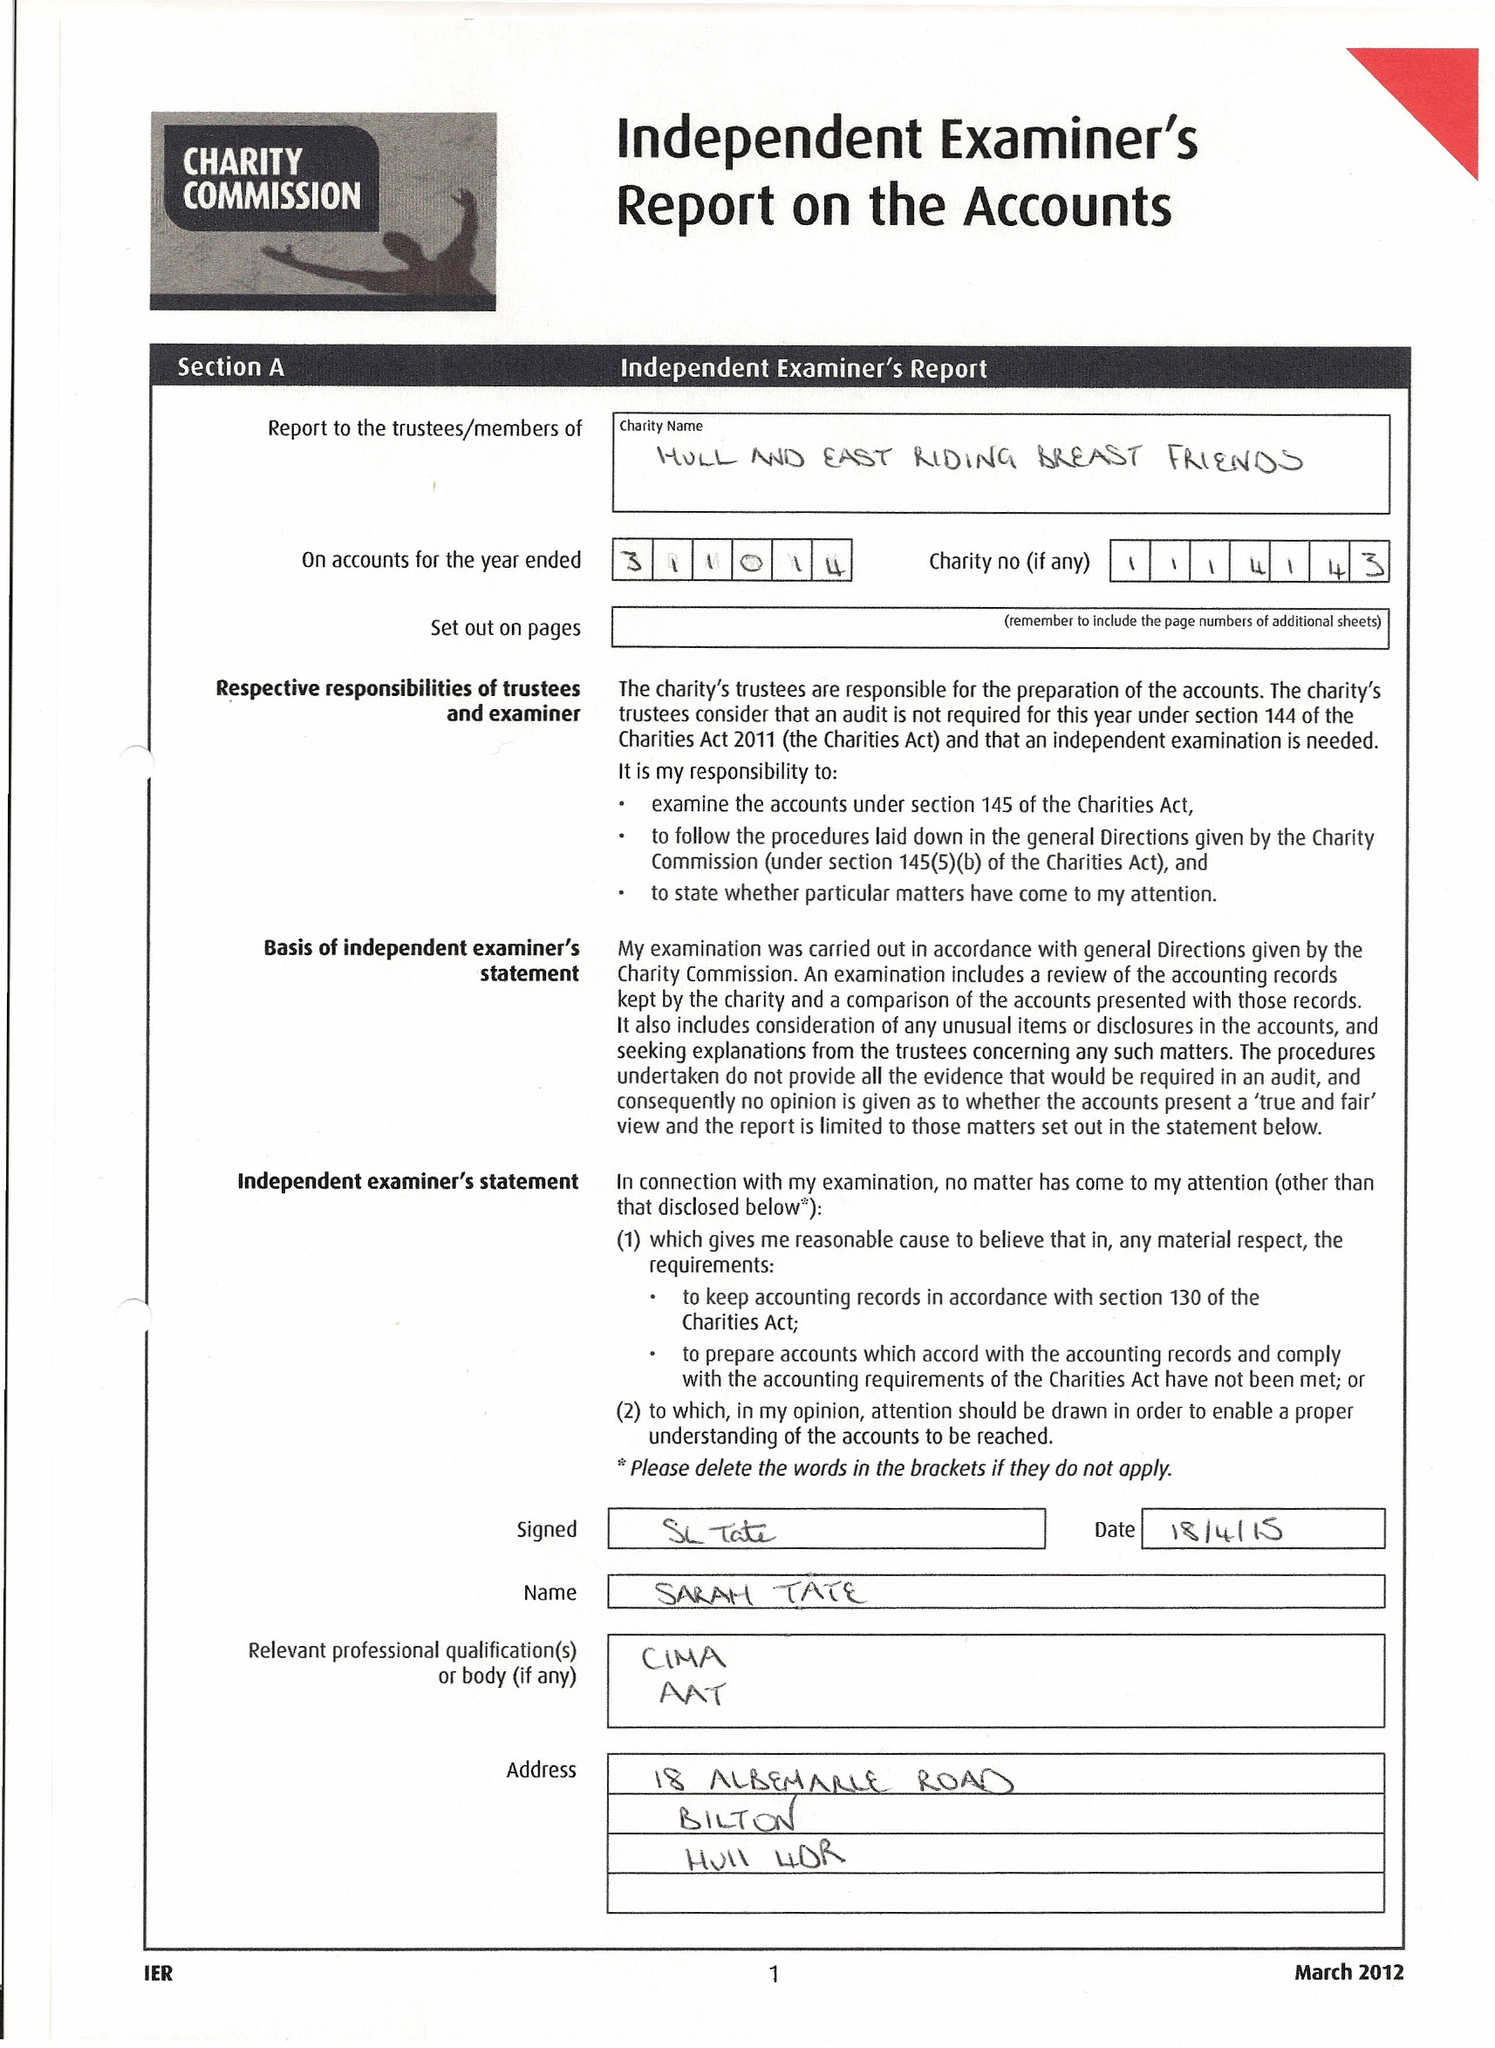What is the value for the income_annually_in_british_pounds?
Answer the question using a single word or phrase. 50341.00 